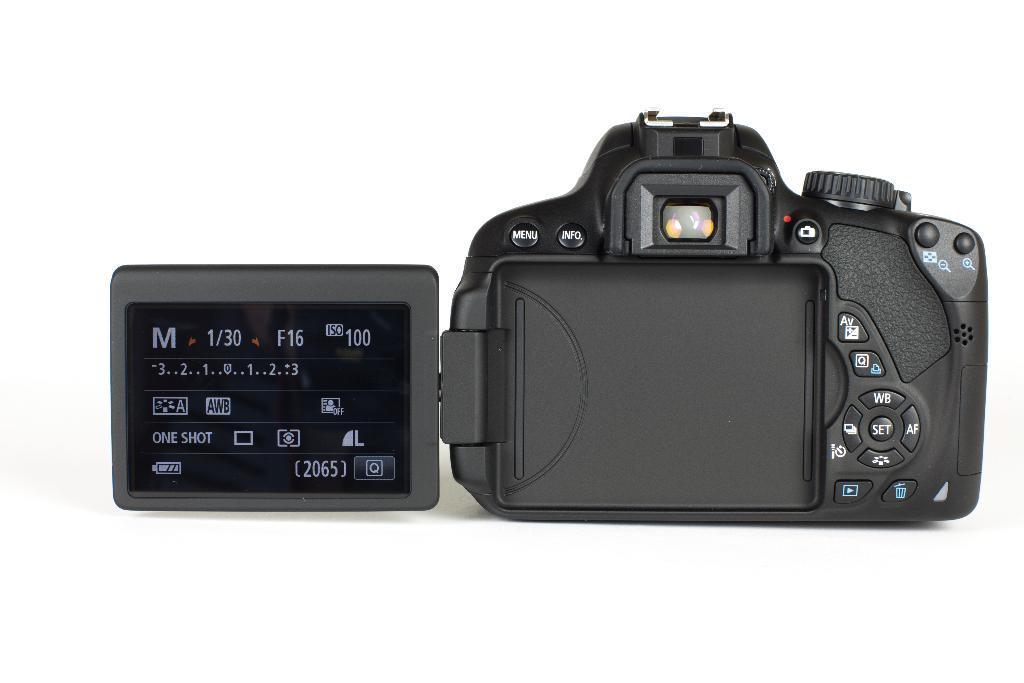In one or two sentences, can you explain what this image depicts? In the foreground of this image, there is a camera on the white surface. 